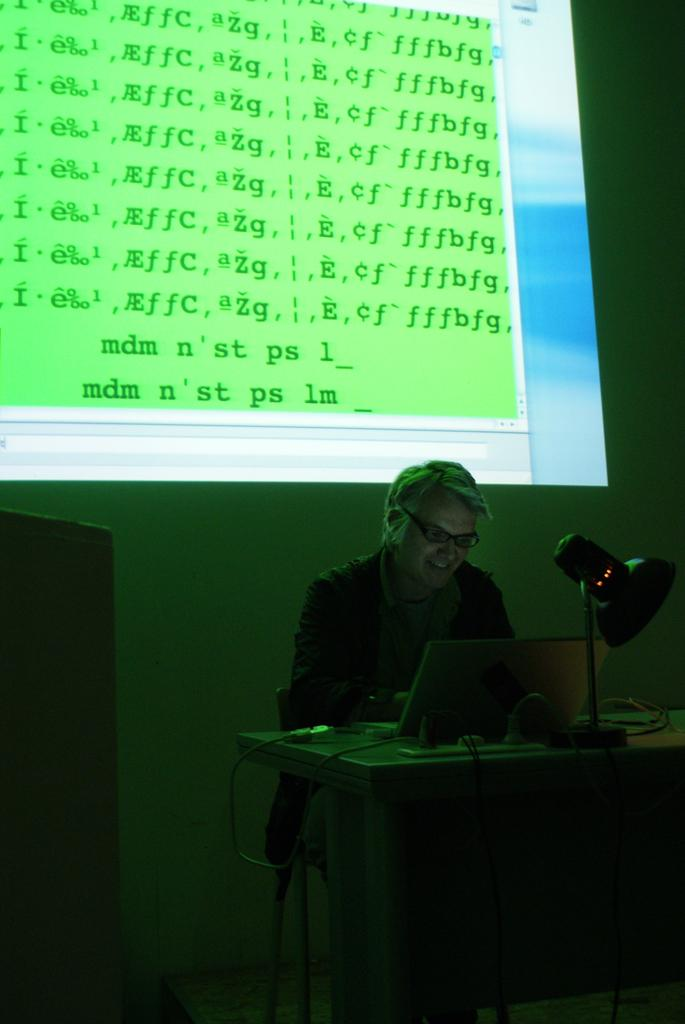What is the main object in the image? There is a screen in the image. What can be seen behind the screen? There is a wall in the image. What is the person in the image doing? There is a person sitting on a chair in the image. What furniture is present in the image? There is a table in the image. What is on the table? There is a lamp and papers on the table. Can you see any cabbage growing in the park in the image? There is no park or cabbage present in the image. How many planes are flying over the person's head in the image? There are no planes visible in the image. 